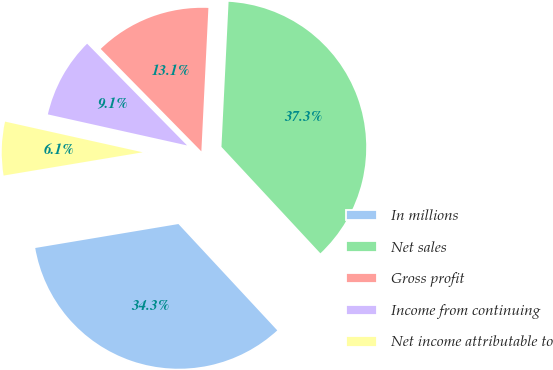Convert chart to OTSL. <chart><loc_0><loc_0><loc_500><loc_500><pie_chart><fcel>In millions<fcel>Net sales<fcel>Gross profit<fcel>Income from continuing<fcel>Net income attributable to<nl><fcel>34.28%<fcel>37.3%<fcel>13.14%<fcel>9.15%<fcel>6.13%<nl></chart> 